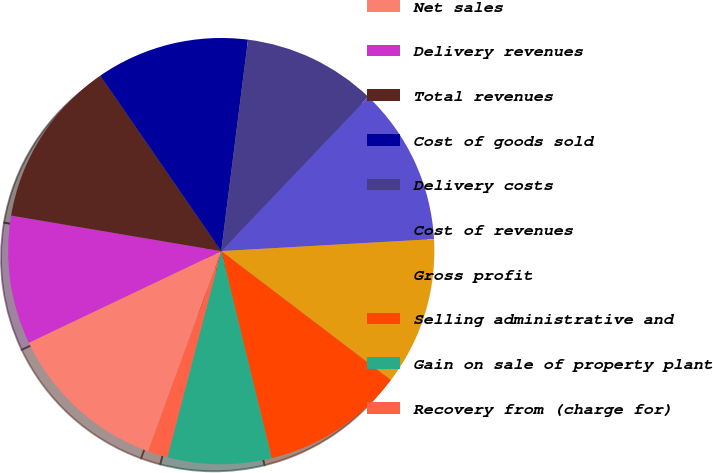<chart> <loc_0><loc_0><loc_500><loc_500><pie_chart><fcel>Net sales<fcel>Delivery revenues<fcel>Total revenues<fcel>Cost of goods sold<fcel>Delivery costs<fcel>Cost of revenues<fcel>Gross profit<fcel>Selling administrative and<fcel>Gain on sale of property plant<fcel>Recovery from (charge for)<nl><fcel>12.36%<fcel>9.74%<fcel>12.73%<fcel>11.61%<fcel>10.11%<fcel>11.99%<fcel>11.24%<fcel>10.86%<fcel>7.87%<fcel>1.5%<nl></chart> 